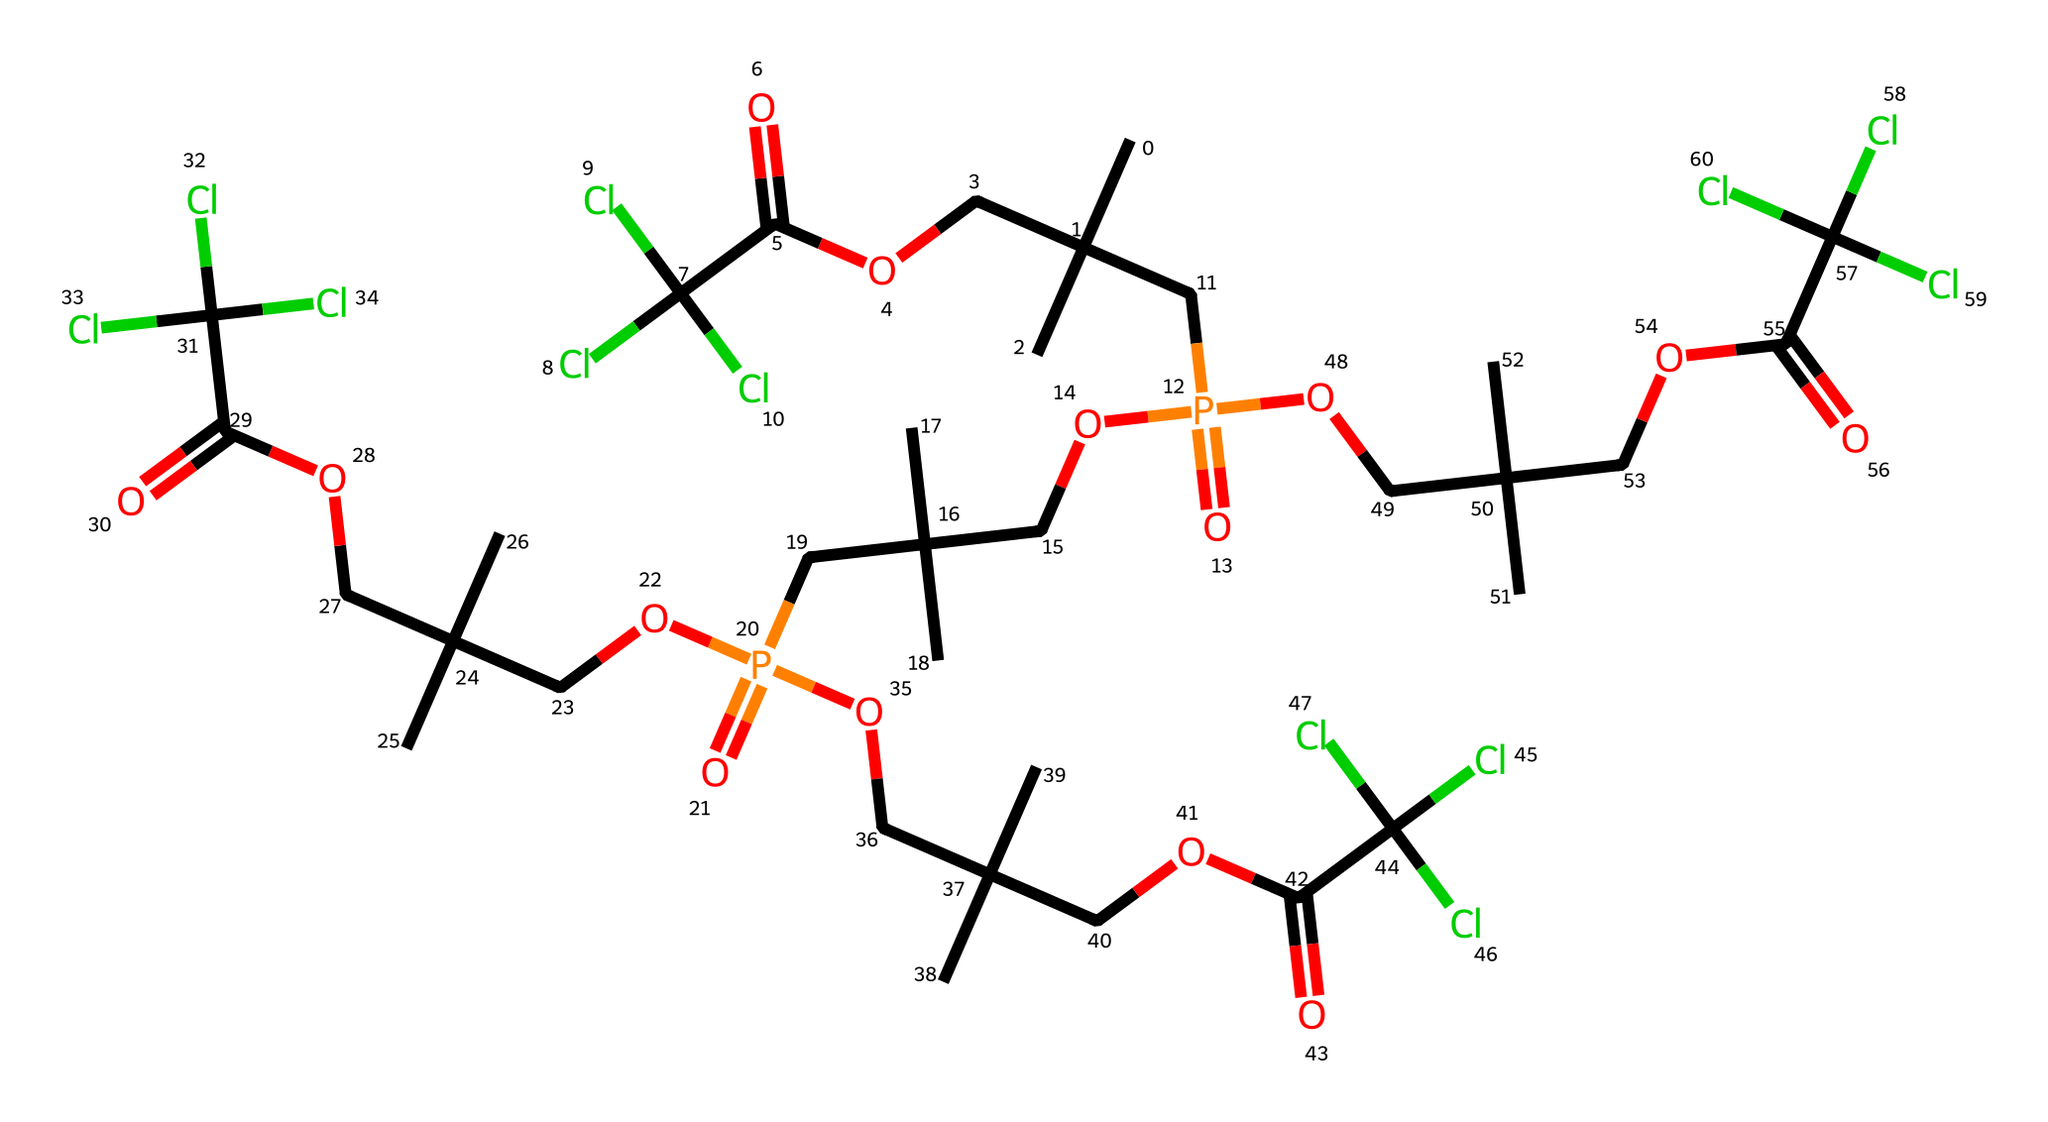How many phosphorus atoms are present in this compound? By analyzing the SMILES representation, we can identify phosphorus atoms denoted by "P." In the provided structure, there are three occurrences of "P."
Answer: three What is the maximum number of chlorine substituents found in this compound? The presence of "Cl" in the SMILES indicates chlorine atoms. Counting the "Cl" entries shows there are six chlorine atoms in total.
Answer: six Which functional group is primarily responsible for the flame retardant properties in this compound? The presence of the phosphate group, indicated by "P(=O)", is crucial for flame-retardant properties, as phosphorus-based flame retardants typically contain this functional group.
Answer: phosphate What is the overall molecular hybridization of the phosphorus atoms in this structure? The presence of phosphorus with oxygen and carbon attachments suggests a tetrahedral geometry attributed to sp3 hybridization, common for phosphorus in organophosphates.
Answer: sp3 Does this compound have ester linkages in its structure? The "COC(=O)" segments in the SMILES indicate the presence of ester functional groups, which are typical in organophosphate compounds used in flame retardants.
Answer: yes What is the significance of the alkyl groups present in this compound? The multiple "CC(C)(C)" portions featuring carbon chains contribute to the hydrophobic characteristics, which can enhance the effectiveness of the flame retardant by reducing water solubility.
Answer: hydrophobic 